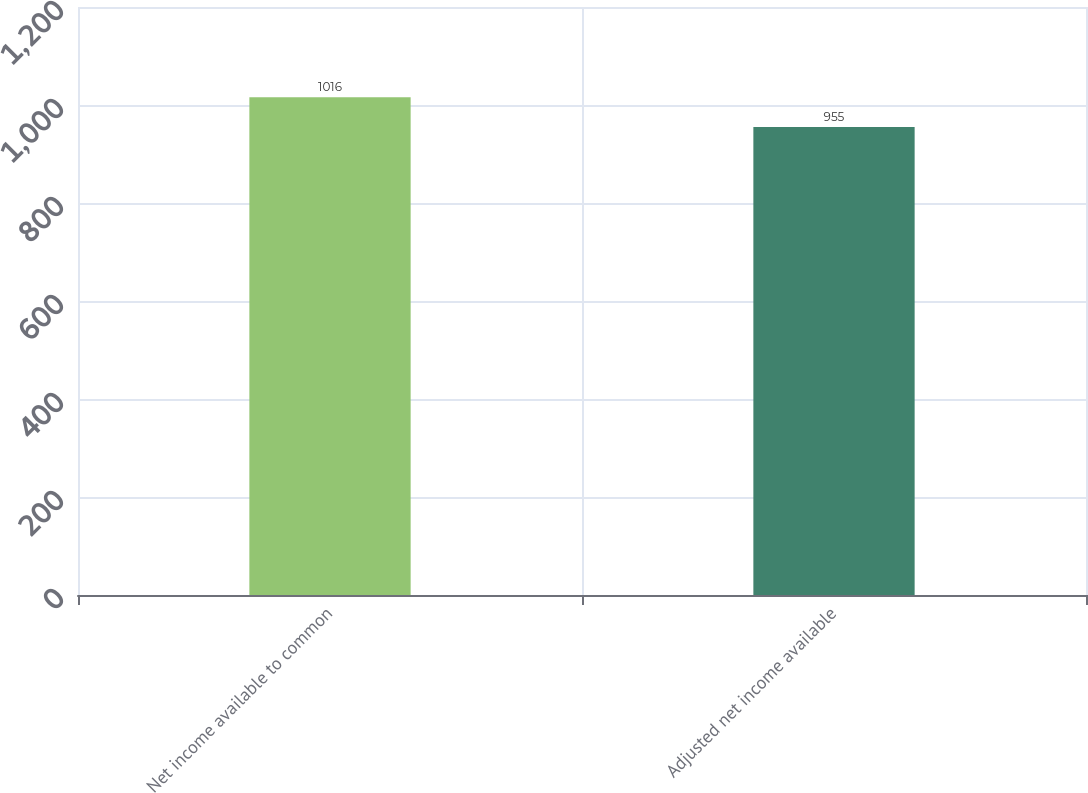<chart> <loc_0><loc_0><loc_500><loc_500><bar_chart><fcel>Net income available to common<fcel>Adjusted net income available<nl><fcel>1016<fcel>955<nl></chart> 